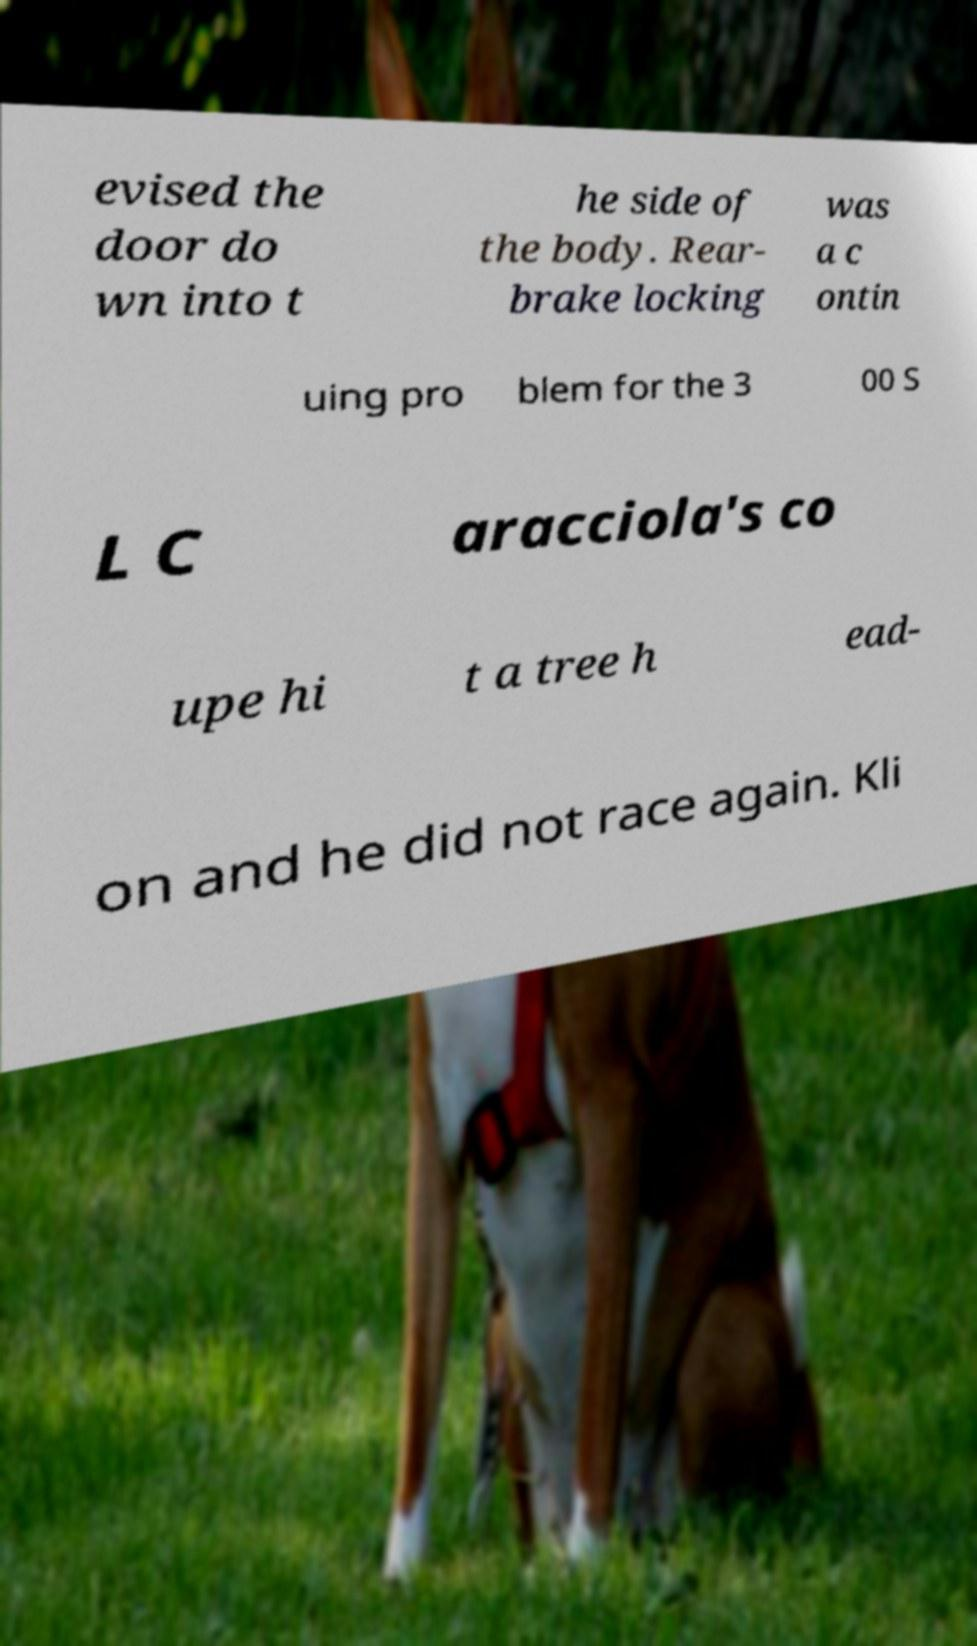Could you assist in decoding the text presented in this image and type it out clearly? evised the door do wn into t he side of the body. Rear- brake locking was a c ontin uing pro blem for the 3 00 S L C aracciola's co upe hi t a tree h ead- on and he did not race again. Kli 